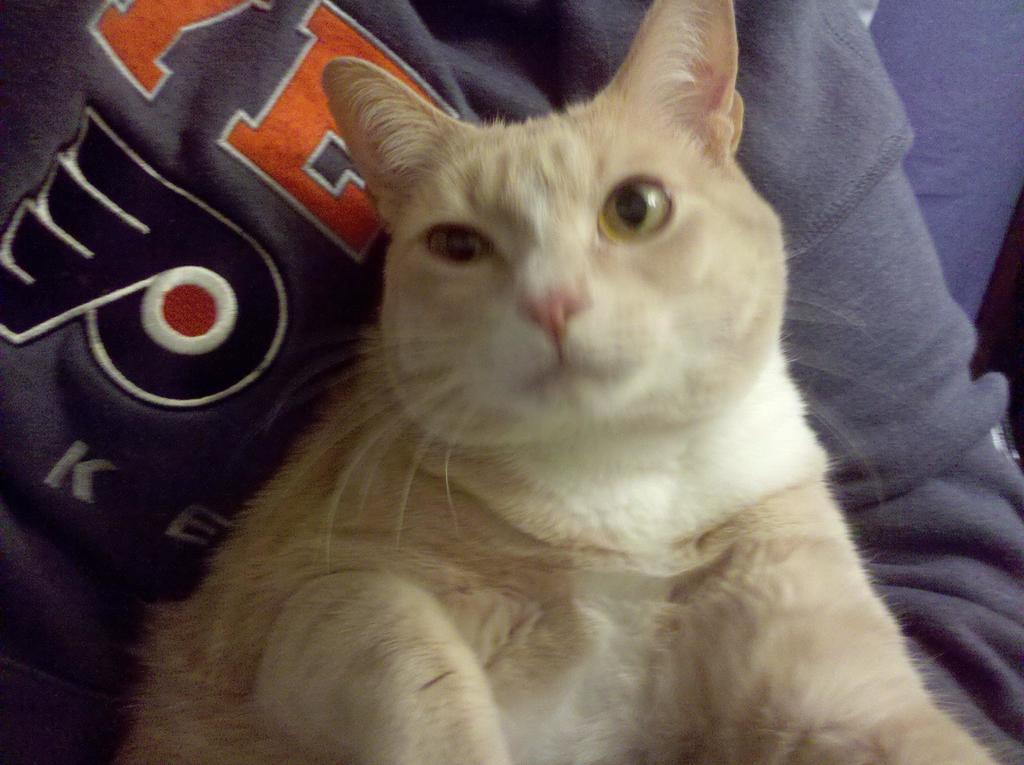What type of animal is in the image? There is a cat in the image. What is the cat doing in the image? The cat is sitting. What color is the cat in the image? The cat is white in color. How does the cat's idea change throughout the image? There is no indication in the image that the cat has any ideas or thoughts, so it cannot be determined if they change. 